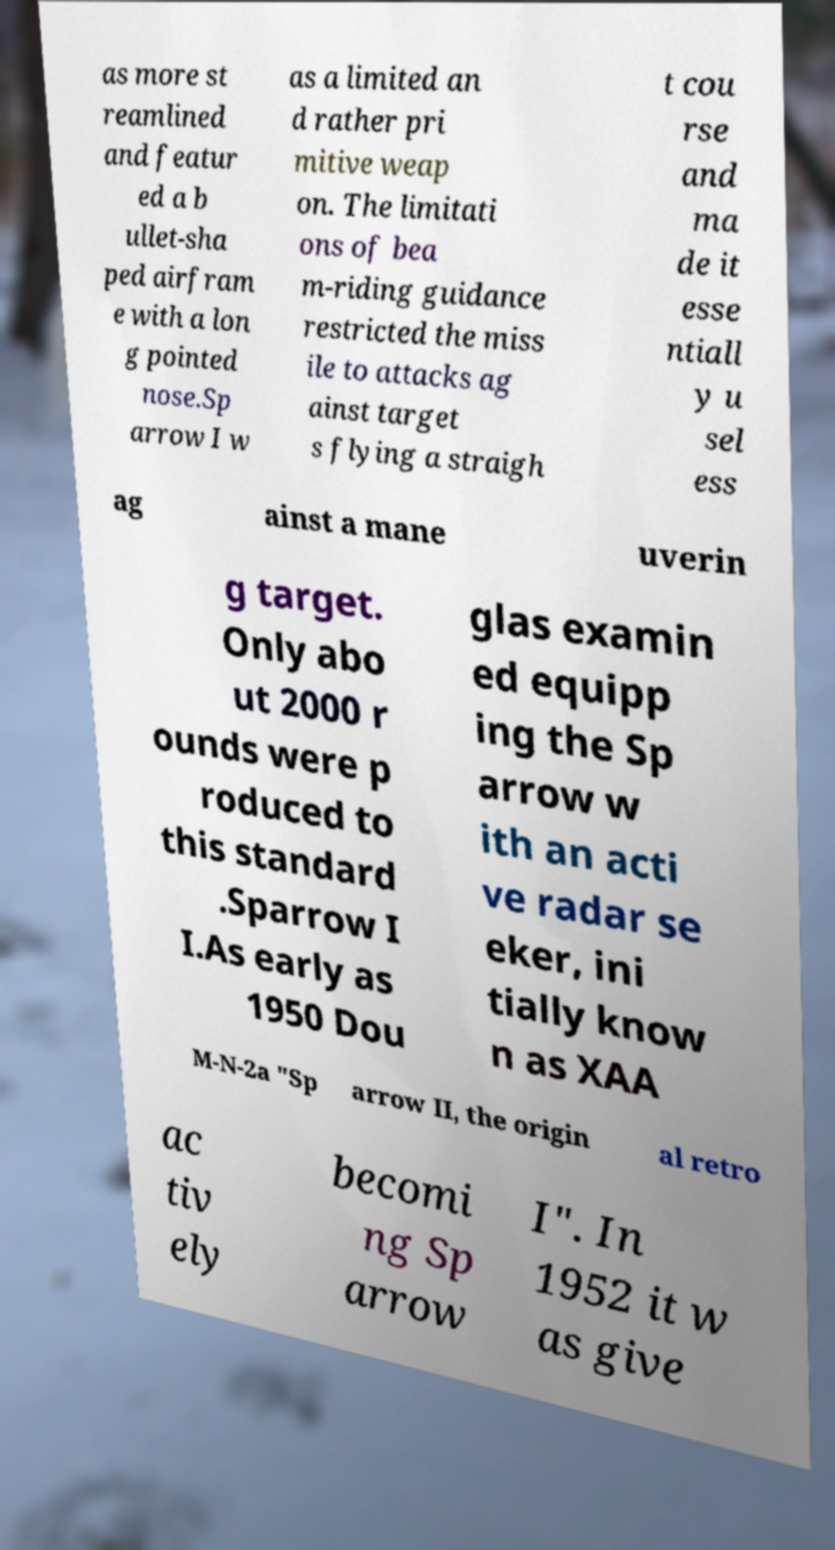Could you assist in decoding the text presented in this image and type it out clearly? as more st reamlined and featur ed a b ullet-sha ped airfram e with a lon g pointed nose.Sp arrow I w as a limited an d rather pri mitive weap on. The limitati ons of bea m-riding guidance restricted the miss ile to attacks ag ainst target s flying a straigh t cou rse and ma de it esse ntiall y u sel ess ag ainst a mane uverin g target. Only abo ut 2000 r ounds were p roduced to this standard .Sparrow I I.As early as 1950 Dou glas examin ed equipp ing the Sp arrow w ith an acti ve radar se eker, ini tially know n as XAA M-N-2a "Sp arrow II, the origin al retro ac tiv ely becomi ng Sp arrow I". In 1952 it w as give 